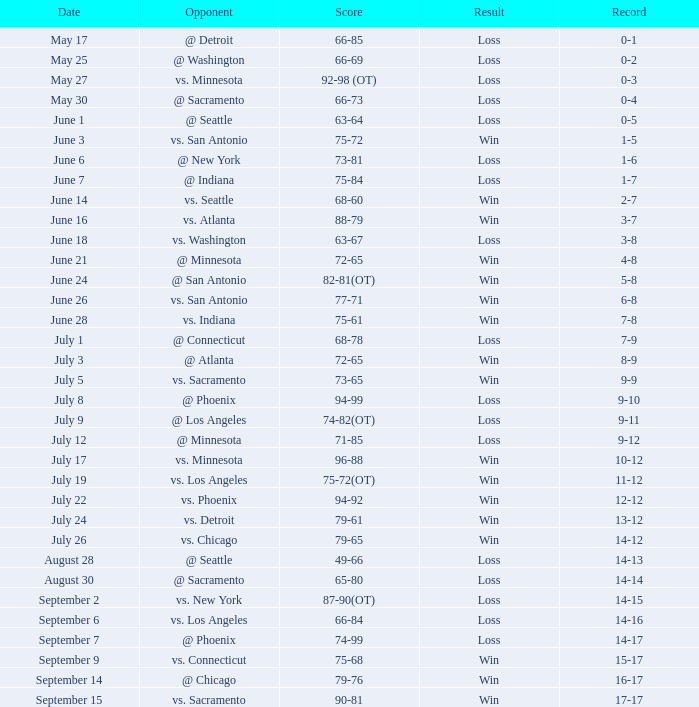Can you provide the game record for june 24? 5-8. 